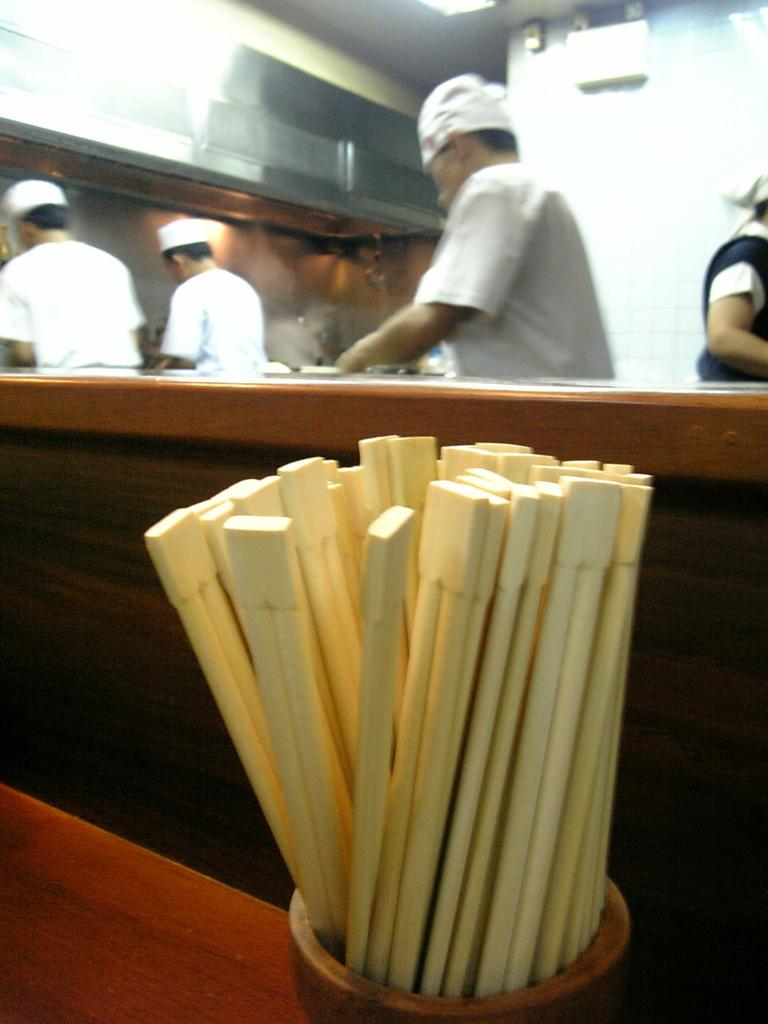How many people are in the image? There are four persons in the image. What are the persons wearing on their heads? The persons are wearing caps. What are the persons doing in the image? The persons are engaged in kitchen activities. What type of bowl is present in the image? There is a wooden bowl in the image. What is inside the wooden bowl? The wooden bowl contains sticks. What type of trail can be seen in the image? There is no trail present in the image; it features four persons engaged in kitchen activities. What is the relation between the persons in the image? The provided facts do not give any information about the relationship between the persons in the image. 